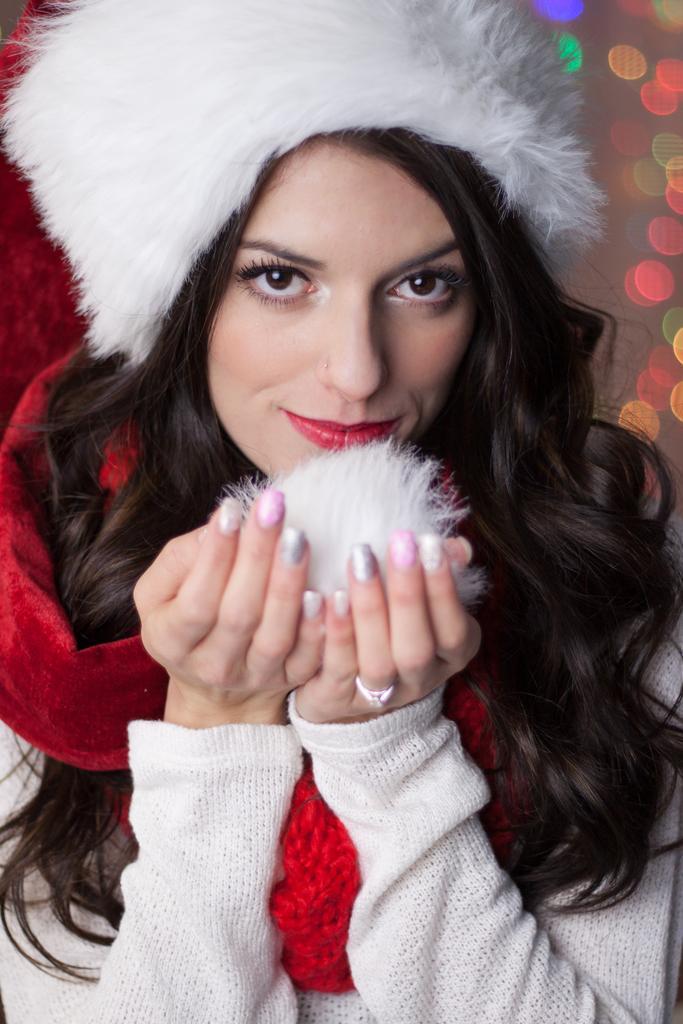Can you describe this image briefly? In this image we can see a lady, there is an object in her hands, and the background is blurred. 